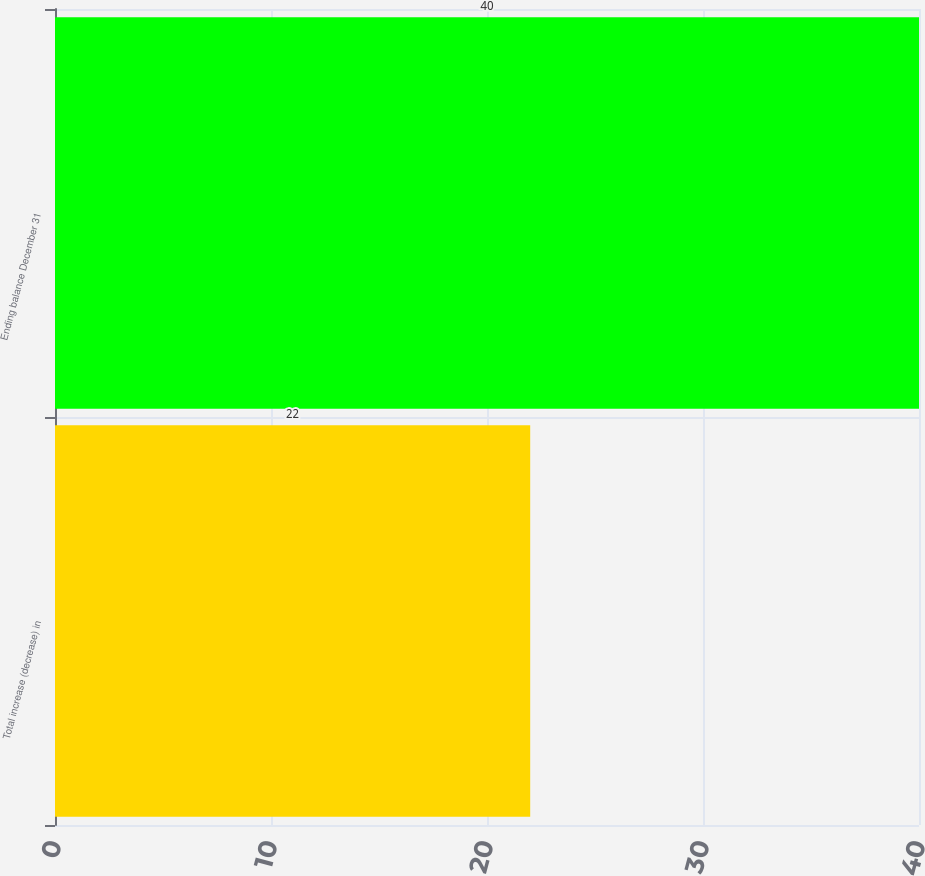Convert chart to OTSL. <chart><loc_0><loc_0><loc_500><loc_500><bar_chart><fcel>Total increase (decrease) in<fcel>Ending balance December 31<nl><fcel>22<fcel>40<nl></chart> 